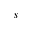Convert formula to latex. <formula><loc_0><loc_0><loc_500><loc_500>s</formula> 